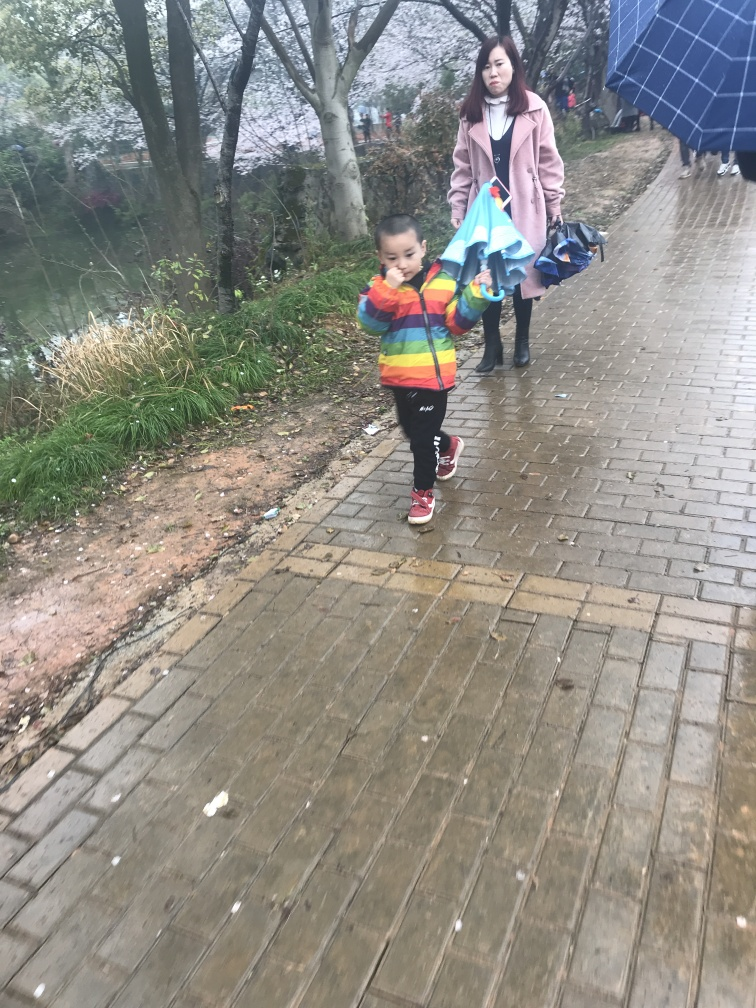Does the image have any blurriness? The photograph does exhibit signs of blurriness, particularly noticeable around the edges and in the movement of the child, suggesting that the image may have been captured while in motion or with a lower shutter speed. 